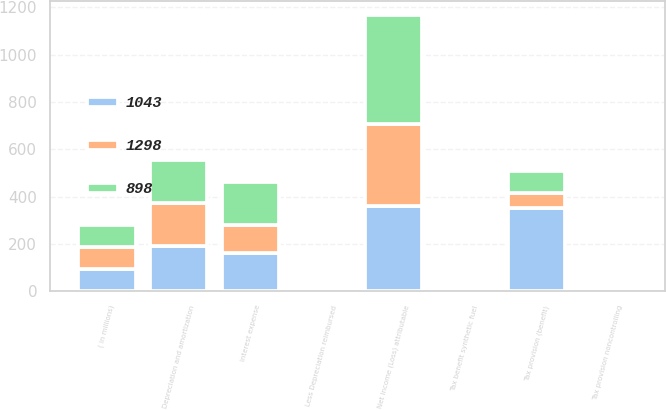Convert chart. <chart><loc_0><loc_0><loc_500><loc_500><stacked_bar_chart><ecel><fcel>( in millions)<fcel>Net Income (Loss) attributable<fcel>Interest expense<fcel>Tax provision (benefit)<fcel>Tax provision noncontrolling<fcel>Tax benefit synthetic fuel<fcel>Depreciation and amortization<fcel>Less Depreciation reimbursed<nl><fcel>898<fcel>93<fcel>458<fcel>180<fcel>93<fcel>0<fcel>0<fcel>178<fcel>11<nl><fcel>1298<fcel>93<fcel>346<fcel>118<fcel>65<fcel>4<fcel>0<fcel>185<fcel>9<nl><fcel>1043<fcel>93<fcel>362<fcel>163<fcel>350<fcel>9<fcel>7<fcel>190<fcel>10<nl></chart> 